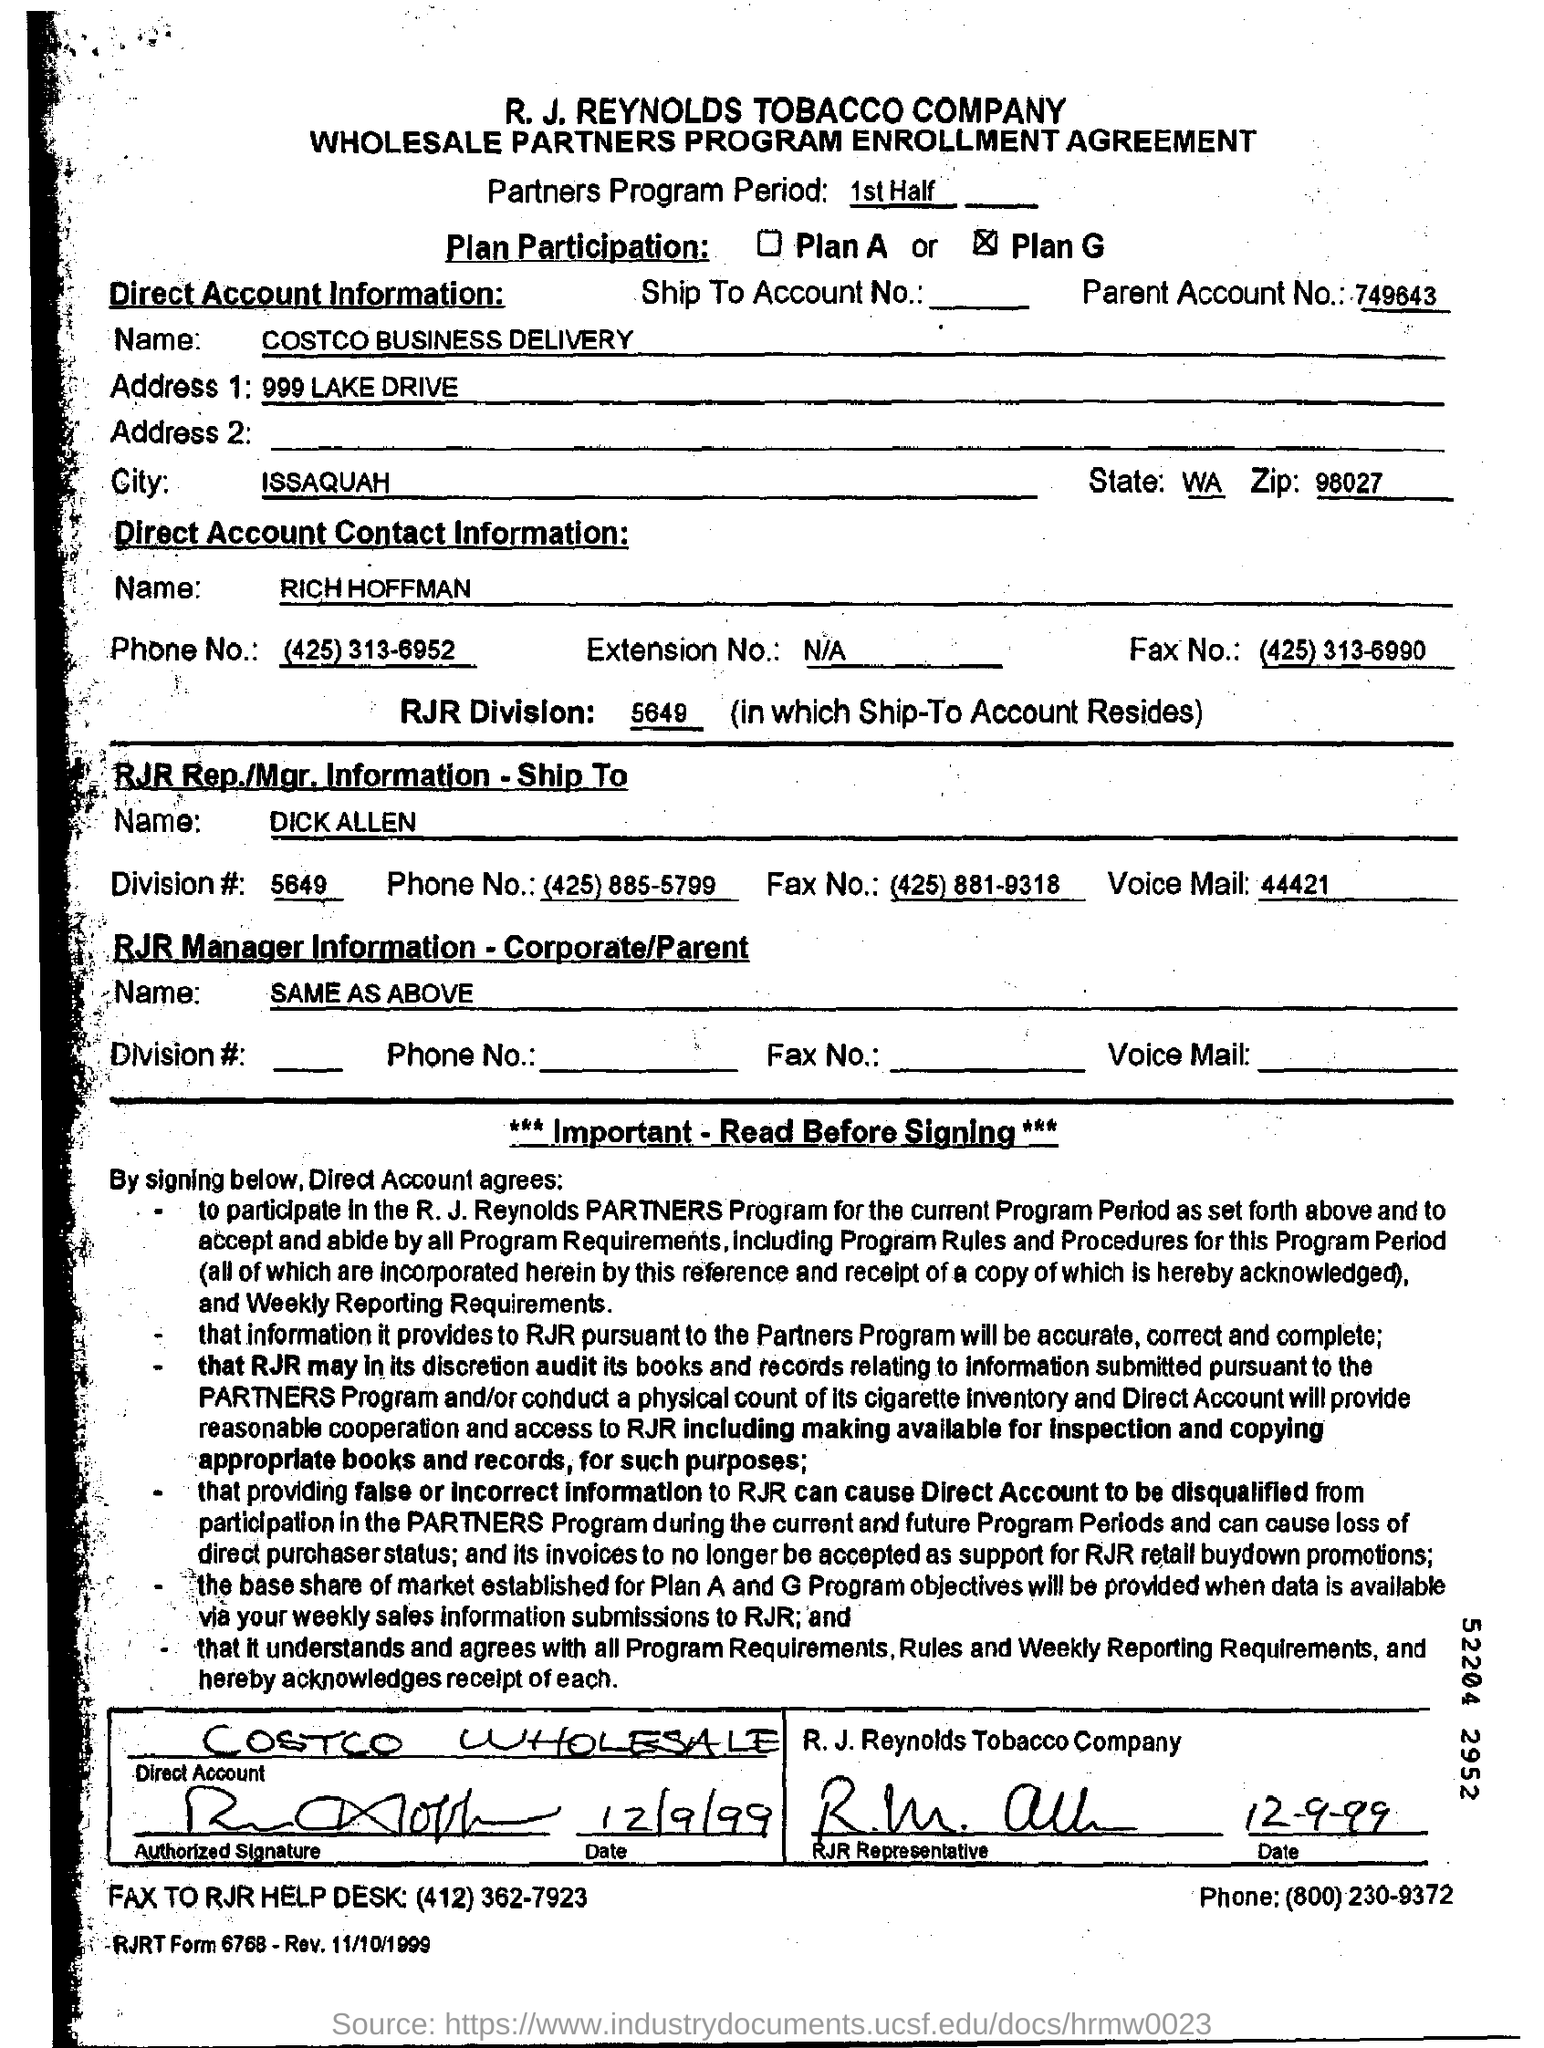List a handful of essential elements in this visual. The ZIP code provided in the "Direct Account Information" is 98027. The information provided in the address field 1 is 999 LAKE DRIVE. The city of ISSAQUAH is mentioned in the Direct Account Information. The parent account number is 749643... The plan participation is X. Plan G... 